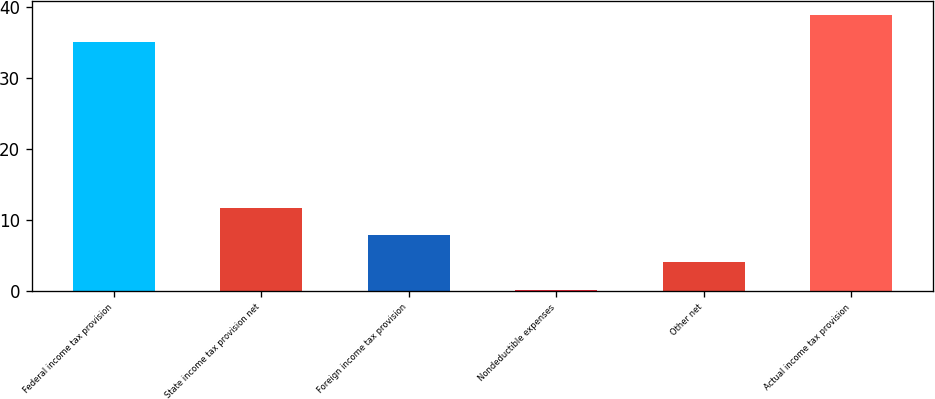Convert chart. <chart><loc_0><loc_0><loc_500><loc_500><bar_chart><fcel>Federal income tax provision<fcel>State income tax provision net<fcel>Foreign income tax provision<fcel>Nondeductible expenses<fcel>Other net<fcel>Actual income tax provision<nl><fcel>35<fcel>11.72<fcel>7.88<fcel>0.2<fcel>4.04<fcel>38.84<nl></chart> 